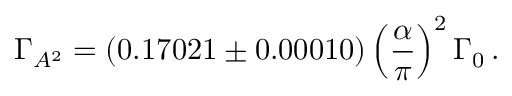Convert formula to latex. <formula><loc_0><loc_0><loc_500><loc_500>\Gamma _ { A ^ { 2 } } = ( 0 . 1 7 0 2 1 \pm 0 . 0 0 0 1 0 ) \left ( \frac { \alpha } { \pi } \right ) ^ { 2 } \Gamma _ { 0 } \, .</formula> 